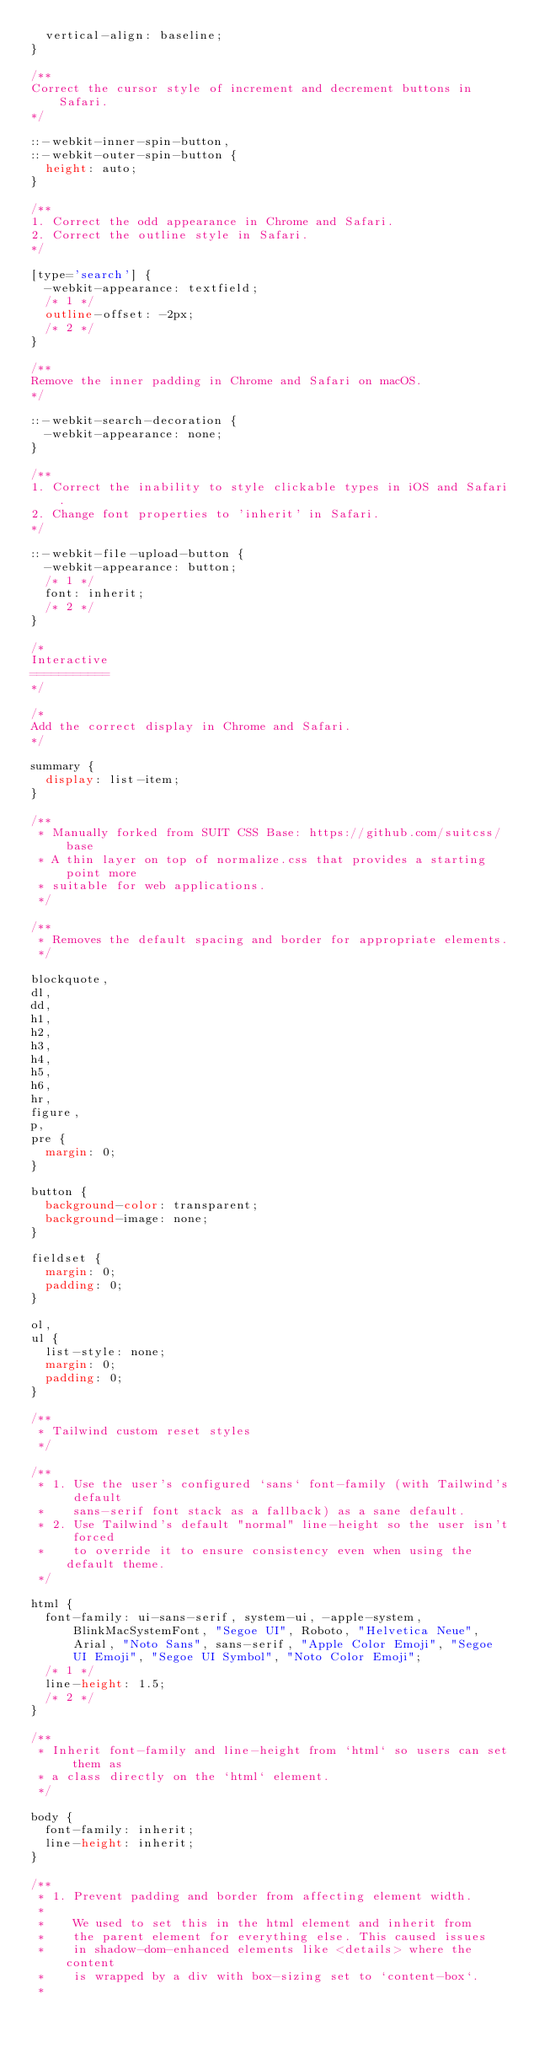Convert code to text. <code><loc_0><loc_0><loc_500><loc_500><_CSS_>  vertical-align: baseline;
}

/**
Correct the cursor style of increment and decrement buttons in Safari.
*/

::-webkit-inner-spin-button,
::-webkit-outer-spin-button {
  height: auto;
}

/**
1. Correct the odd appearance in Chrome and Safari.
2. Correct the outline style in Safari.
*/

[type='search'] {
  -webkit-appearance: textfield;
  /* 1 */
  outline-offset: -2px;
  /* 2 */
}

/**
Remove the inner padding in Chrome and Safari on macOS.
*/

::-webkit-search-decoration {
  -webkit-appearance: none;
}

/**
1. Correct the inability to style clickable types in iOS and Safari.
2. Change font properties to 'inherit' in Safari.
*/

::-webkit-file-upload-button {
  -webkit-appearance: button;
  /* 1 */
  font: inherit;
  /* 2 */
}

/*
Interactive
===========
*/

/*
Add the correct display in Chrome and Safari.
*/

summary {
  display: list-item;
}

/**
 * Manually forked from SUIT CSS Base: https://github.com/suitcss/base
 * A thin layer on top of normalize.css that provides a starting point more
 * suitable for web applications.
 */

/**
 * Removes the default spacing and border for appropriate elements.
 */

blockquote,
dl,
dd,
h1,
h2,
h3,
h4,
h5,
h6,
hr,
figure,
p,
pre {
  margin: 0;
}

button {
  background-color: transparent;
  background-image: none;
}

fieldset {
  margin: 0;
  padding: 0;
}

ol,
ul {
  list-style: none;
  margin: 0;
  padding: 0;
}

/**
 * Tailwind custom reset styles
 */

/**
 * 1. Use the user's configured `sans` font-family (with Tailwind's default
 *    sans-serif font stack as a fallback) as a sane default.
 * 2. Use Tailwind's default "normal" line-height so the user isn't forced
 *    to override it to ensure consistency even when using the default theme.
 */

html {
  font-family: ui-sans-serif, system-ui, -apple-system, BlinkMacSystemFont, "Segoe UI", Roboto, "Helvetica Neue", Arial, "Noto Sans", sans-serif, "Apple Color Emoji", "Segoe UI Emoji", "Segoe UI Symbol", "Noto Color Emoji";
  /* 1 */
  line-height: 1.5;
  /* 2 */
}

/**
 * Inherit font-family and line-height from `html` so users can set them as
 * a class directly on the `html` element.
 */

body {
  font-family: inherit;
  line-height: inherit;
}

/**
 * 1. Prevent padding and border from affecting element width.
 *
 *    We used to set this in the html element and inherit from
 *    the parent element for everything else. This caused issues
 *    in shadow-dom-enhanced elements like <details> where the content
 *    is wrapped by a div with box-sizing set to `content-box`.
 *</code> 